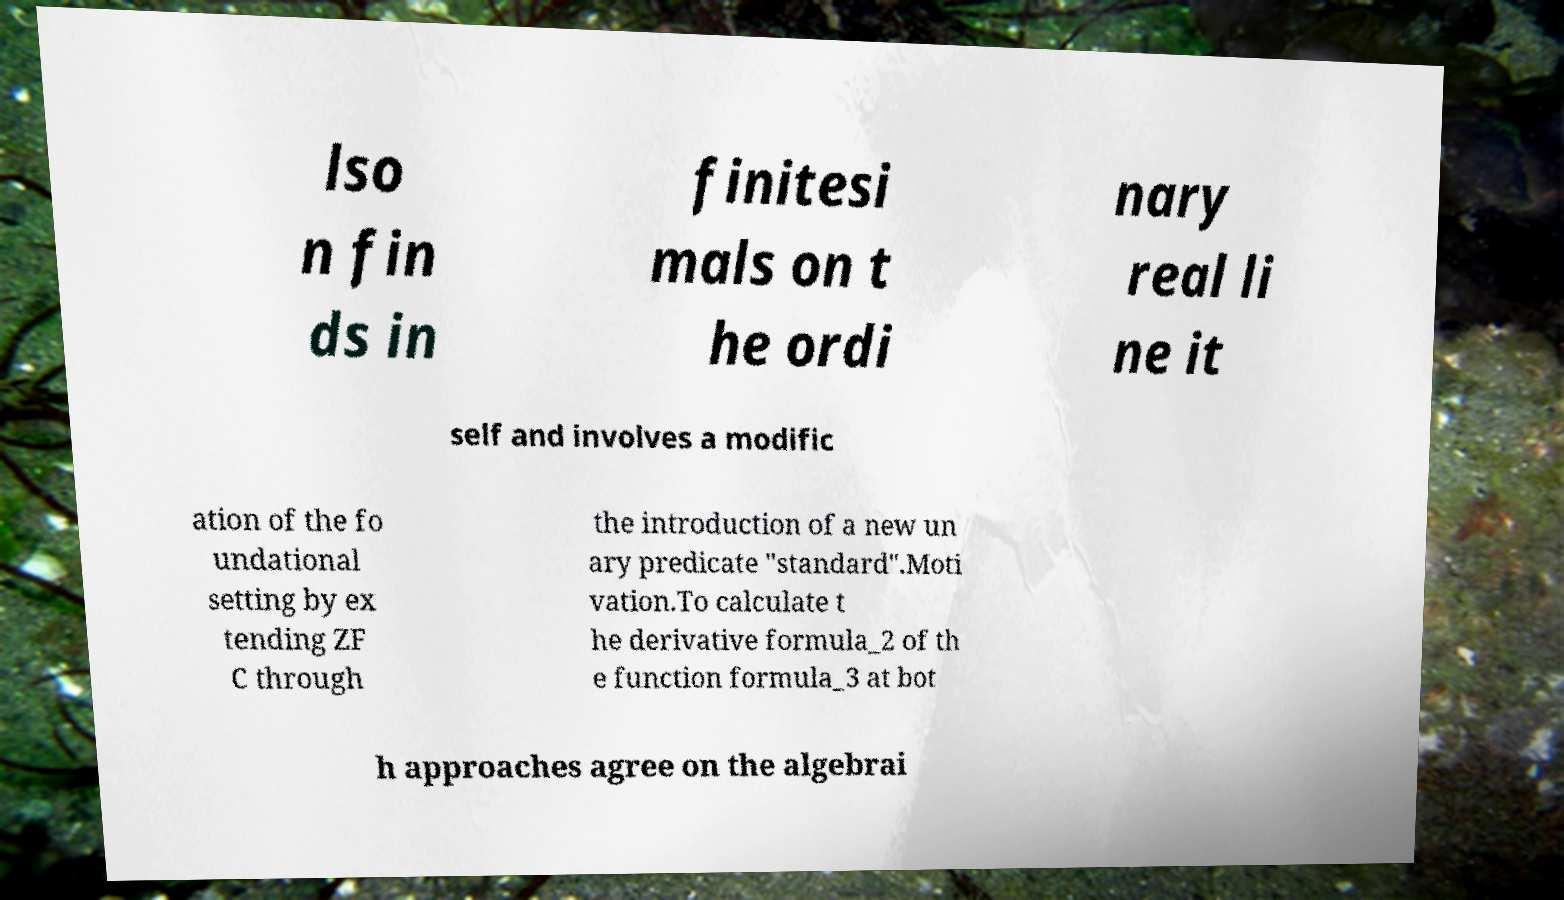There's text embedded in this image that I need extracted. Can you transcribe it verbatim? lso n fin ds in finitesi mals on t he ordi nary real li ne it self and involves a modific ation of the fo undational setting by ex tending ZF C through the introduction of a new un ary predicate "standard".Moti vation.To calculate t he derivative formula_2 of th e function formula_3 at bot h approaches agree on the algebrai 